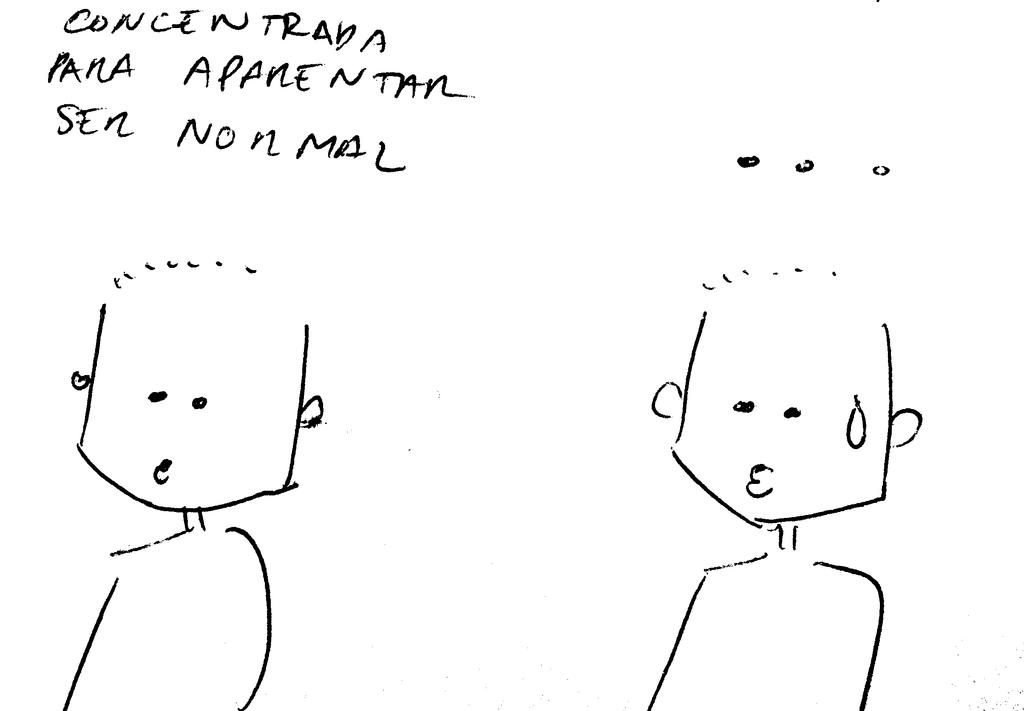What is the main subject of the image? The main subject of the image is a sketch of cartoons. What else can be seen in the image besides the cartoon sketch? There is some text in the image. What type of pleasure can be seen being derived from the cabbage in the image? There is no cabbage present in the image, and therefore no such pleasure can be observed. 